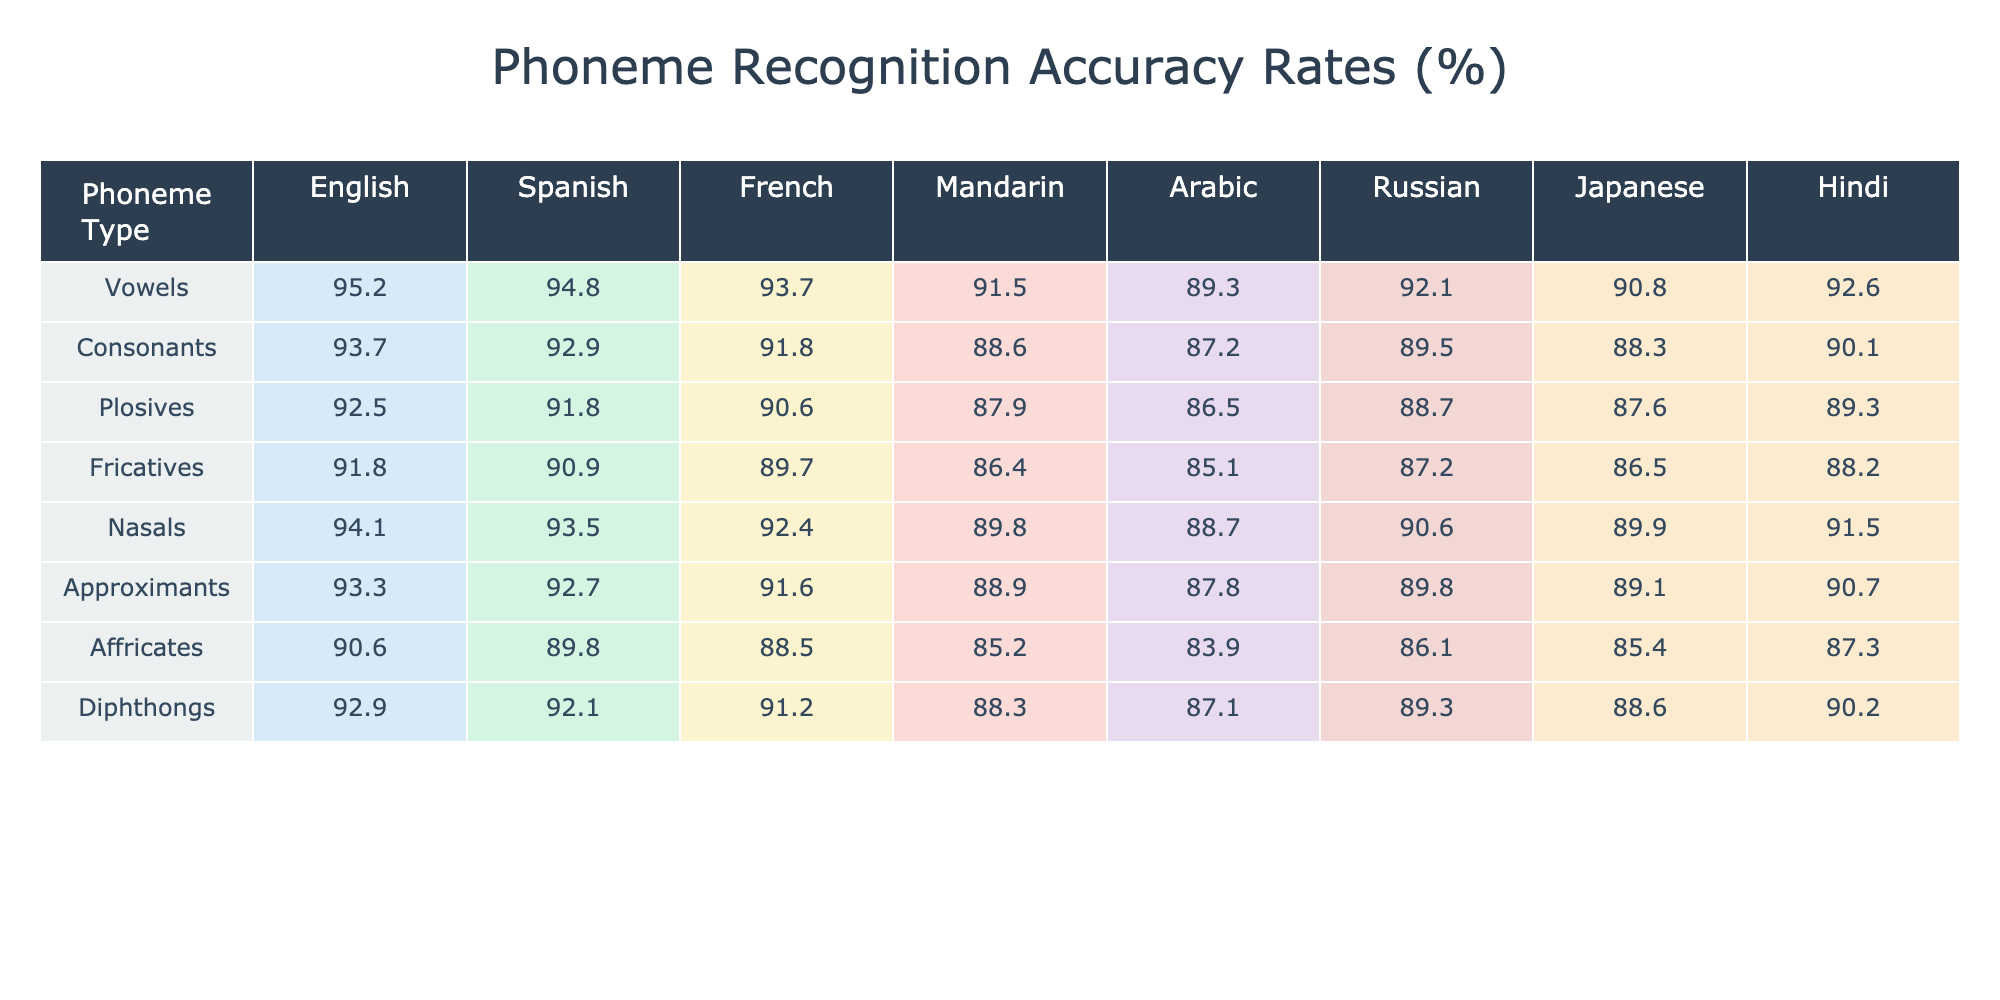What is the phoneme recognition accuracy rate for vowels in Spanish? The table indicates that the vowel recognition accuracy rate for Spanish is listed under the Spanish column and the Vowels row, which displays a value of 94.8%.
Answer: 94.8% Which language has the highest accuracy rate for nasals? The highest accuracy rate for nasals is found by comparing the values in the Nasals row across all languages. The highest value is 94.1%, corresponding to English.
Answer: English What is the difference in accuracy rates for fricatives between Russian and Arabic? To find the difference, locate the fricative row and read the associated values for Russian (87.2%) and Arabic (85.1%). Subtract the two: 87.2% - 85.1% = 2.1%.
Answer: 2.1% Is the phoneme recognition accuracy for plosives higher in Hindi than in Mandarin? Check the Plosives row for both Hindi (89.3%) and Mandarin (87.9%). Since 89.3% is greater than 87.9%, the statement is true.
Answer: Yes What is the average accuracy rate for consonants across all languages? To calculate the average, sum the consonant accuracy rates: 93.7 + 92.9 + 91.8 + 88.6 + 87.2 + 89.5 + 88.3 + 90.1 = 722.1. There are 8 languages, so divide 722.1 by 8, resulting in an average of 90.2625%.
Answer: 90.3% Which language has the lowest accuracy rate for affricates? By evaluating the Affricates row, the lowest value is in Arabic, which is 83.9%.
Answer: Arabic How do the accuracy rates for vowels compare between Japanese and Hindi? The vowel recognition accuracy rates are 90.8% for Japanese and 92.6% for Hindi. Hindi’s rate is higher than Japanese’s by comparing the two values: 92.6% - 90.8% = 1.8%.
Answer: Hindi is higher by 1.8% What is the overall trend for the recognition of fricatives across the different languages? To analyze the trend, observe the accuracy rates for fricatives in sequence: decreasing from English (91.8%) to Arabic (85.1%). Clearly, there is a downward trend.
Answer: Downward trend Which phoneme type has the highest accuracy rate in Spanish? Looking at the Spanish column, the highest accuracy rate is for vowels at 94.8%, which is higher than other phoneme types.
Answer: Vowels What is the total accuracy for approximants across all languages? The accuracy rates for approximants are: 93.3%, 92.7%, 91.6%, 88.9%, 87.8%, 89.8%, 89.1%, and 90.7%. Calculate the sum: 93.3 + 92.7 + 91.6 + 88.9 + 87.8 + 89.8 + 89.1 + 90.7 = 723.9.
Answer: 723.9 